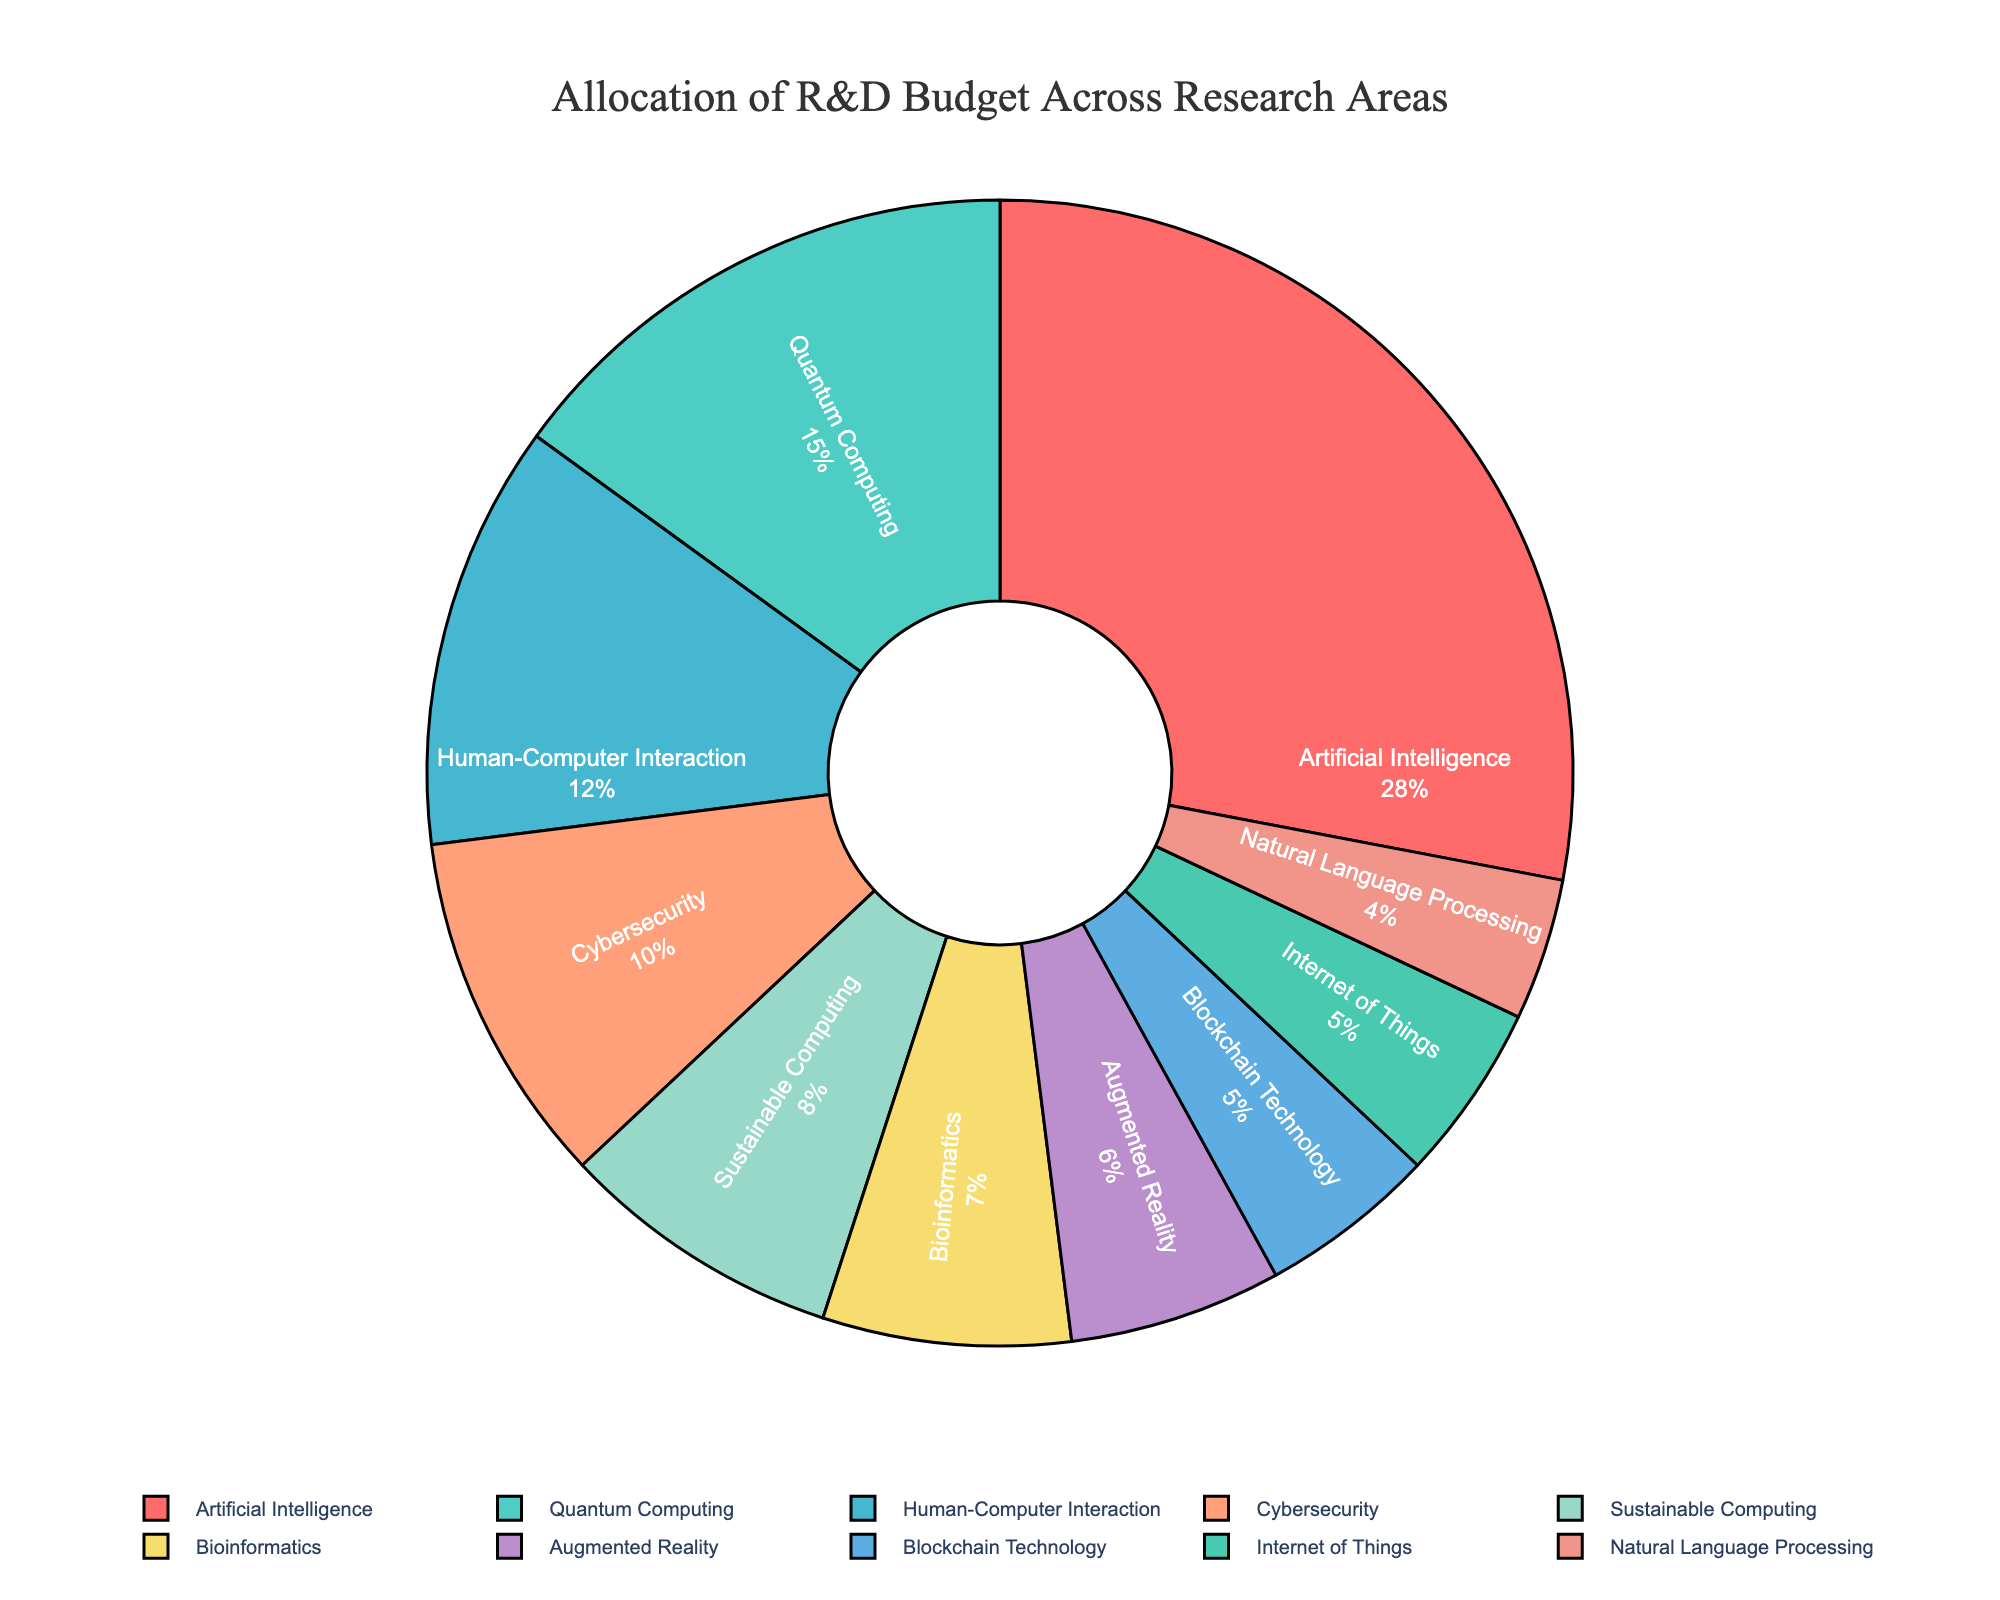Which research area has the highest allocation of the R&D budget? The figure clearly shows that Artificial Intelligence has the largest slice of the pie chart, indicating the highest budget allocation.
Answer: Artificial Intelligence What is the combined budget allocation for Cybersecurity and Bioinformatics? According to the pie chart, Cybersecurity is allocated 10% of the budget and Bioinformatics is allocated 7%. Their combined allocation is 10% + 7% = 17%.
Answer: 17% Which research area has a smaller budget allocation: Augmented Reality or Blockchain Technology? The slices corresponding to Augmented Reality and Blockchain Technology show that Augmented Reality is allocated 6% of the budget, whereas Blockchain Technology is allocated 5%. Hence, Blockchain Technology has a smaller budget allocation.
Answer: Blockchain Technology How much more budget is allocated to Quantum Computing compared to Sustainable Computing? The pie chart shows that Quantum Computing is allocated 15% of the budget, and Sustainable Computing is allocated 8%. The difference is 15% - 8% = 7%.
Answer: 7% What percentage of the budget is allocated to all areas combined except the top two areas? The top two areas are Artificial Intelligence (28%) and Quantum Computing (15%), summing up to 43%. The total budget is 100%, so the remaining allocation is 100% - 43% = 57%.
Answer: 57% What is the total allocation for the three least funded research areas? The three least funded research areas are Natural Language Processing (4%), Internet of Things (5%), and Blockchain Technology (5%). Their total allocation is 4% + 5% + 5% = 14%.
Answer: 14% Which color represents Human-Computer Interaction in the pie chart? Looking at the pie chart, Human-Computer Interaction is represented by the slice colored in light blue.
Answer: Light blue Are there any research areas with an equal budget allocation? If so, which ones? The pie chart shows that both Blockchain Technology and Internet of Things are allocated 5% of the R&D budget, thus they have equal budget allocations.
Answer: Blockchain Technology, Internet of Things What is the average budget allocation for Artificial Intelligence, Cybersecurity, and Augmented Reality? The budget allocations for Artificial Intelligence, Cybersecurity, and Augmented Reality are 28%, 10%, and 6% respectively. Their average is (28% + 10% + 6%) / 3 = 44% / 3 = 14.67%.
Answer: 14.67% How does the budget allocation for Human-Computer Interaction compare to that for Bioinformatics and Natural Language Processing combined? Human-Computer Interaction is allocated 12% of the budget. Bioinformatics is allocated 7%, and Natural Language Processing is 4%. Combined, Bioinformatics and Natural Language Processing are 7% + 4% = 11%. Thus, Human-Computer Interaction has a higher budget allocation by 12% - 11% = 1%.
Answer: 1% 